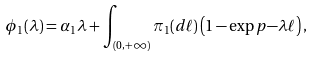Convert formula to latex. <formula><loc_0><loc_0><loc_500><loc_500>\phi _ { 1 } ( \lambda ) = \alpha _ { 1 } \lambda + \int _ { ( 0 , + \infty ) } \pi _ { 1 } ( d \ell ) \left ( 1 - \exp p { - \lambda \ell } \right ) ,</formula> 